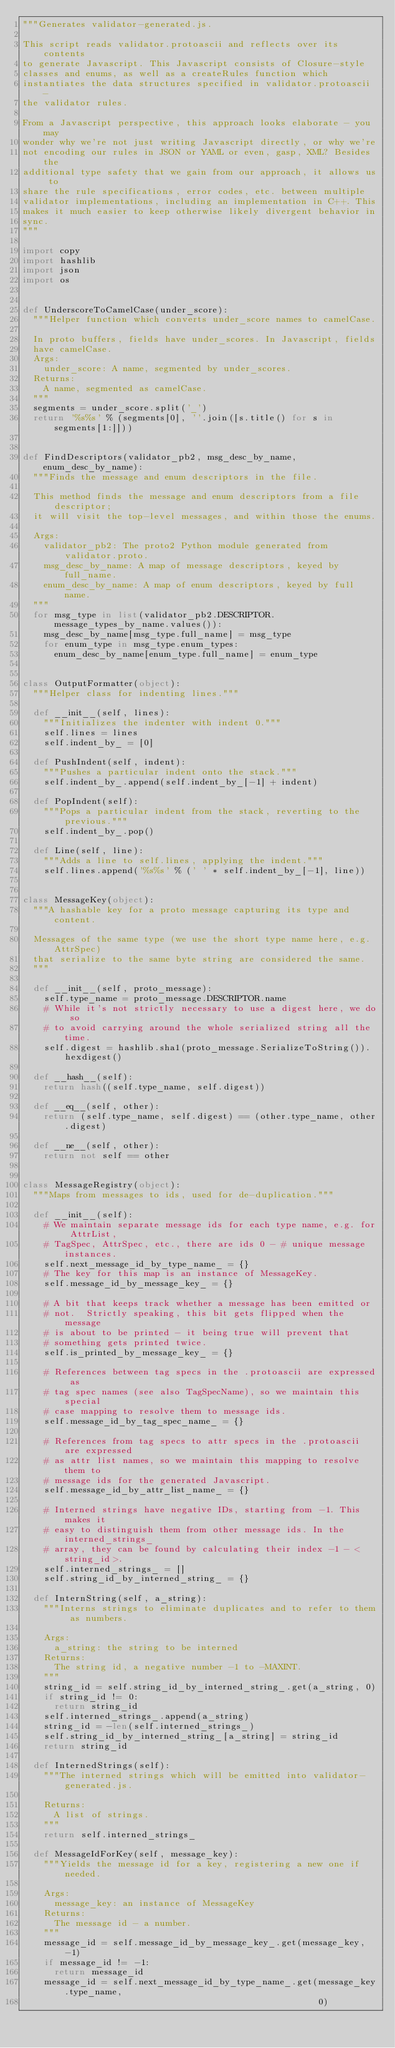Convert code to text. <code><loc_0><loc_0><loc_500><loc_500><_Python_>"""Generates validator-generated.js.

This script reads validator.protoascii and reflects over its contents
to generate Javascript. This Javascript consists of Closure-style
classes and enums, as well as a createRules function which
instantiates the data structures specified in validator.protoascii -
the validator rules.

From a Javascript perspective, this approach looks elaborate - you may
wonder why we're not just writing Javascript directly, or why we're
not encoding our rules in JSON or YAML or even, gasp, XML? Besides the
additional type safety that we gain from our approach, it allows us to
share the rule specifications, error codes, etc. between multiple
validator implementations, including an implementation in C++. This
makes it much easier to keep otherwise likely divergent behavior in
sync.
"""

import copy
import hashlib
import json
import os


def UnderscoreToCamelCase(under_score):
  """Helper function which converts under_score names to camelCase.

  In proto buffers, fields have under_scores. In Javascript, fields
  have camelCase.
  Args:
    under_score: A name, segmented by under_scores.
  Returns:
    A name, segmented as camelCase.
  """
  segments = under_score.split('_')
  return '%s%s' % (segments[0], ''.join([s.title() for s in segments[1:]]))


def FindDescriptors(validator_pb2, msg_desc_by_name, enum_desc_by_name):
  """Finds the message and enum descriptors in the file.

  This method finds the message and enum descriptors from a file descriptor;
  it will visit the top-level messages, and within those the enums.

  Args:
    validator_pb2: The proto2 Python module generated from validator.proto.
    msg_desc_by_name: A map of message descriptors, keyed by full_name.
    enum_desc_by_name: A map of enum descriptors, keyed by full name.
  """
  for msg_type in list(validator_pb2.DESCRIPTOR.message_types_by_name.values()):
    msg_desc_by_name[msg_type.full_name] = msg_type
    for enum_type in msg_type.enum_types:
      enum_desc_by_name[enum_type.full_name] = enum_type


class OutputFormatter(object):
  """Helper class for indenting lines."""

  def __init__(self, lines):
    """Initializes the indenter with indent 0."""
    self.lines = lines
    self.indent_by_ = [0]

  def PushIndent(self, indent):
    """Pushes a particular indent onto the stack."""
    self.indent_by_.append(self.indent_by_[-1] + indent)

  def PopIndent(self):
    """Pops a particular indent from the stack, reverting to the previous."""
    self.indent_by_.pop()

  def Line(self, line):
    """Adds a line to self.lines, applying the indent."""
    self.lines.append('%s%s' % (' ' * self.indent_by_[-1], line))


class MessageKey(object):
  """A hashable key for a proto message capturing its type and content.

  Messages of the same type (we use the short type name here, e.g. AttrSpec)
  that serialize to the same byte string are considered the same.
  """

  def __init__(self, proto_message):
    self.type_name = proto_message.DESCRIPTOR.name
    # While it's not strictly necessary to use a digest here, we do so
    # to avoid carrying around the whole serialized string all the time.
    self.digest = hashlib.sha1(proto_message.SerializeToString()).hexdigest()

  def __hash__(self):
    return hash((self.type_name, self.digest))

  def __eq__(self, other):
    return (self.type_name, self.digest) == (other.type_name, other.digest)

  def __ne__(self, other):
    return not self == other


class MessageRegistry(object):
  """Maps from messages to ids, used for de-duplication."""

  def __init__(self):
    # We maintain separate message ids for each type name, e.g. for AttrList,
    # TagSpec, AttrSpec, etc., there are ids 0 - # unique message instances.
    self.next_message_id_by_type_name_ = {}
    # The key for this map is an instance of MessageKey.
    self.message_id_by_message_key_ = {}

    # A bit that keeps track whether a message has been emitted or
    # not.  Strictly speaking, this bit gets flipped when the message
    # is about to be printed - it being true will prevent that
    # something gets printed twice.
    self.is_printed_by_message_key_ = {}

    # References between tag specs in the .protoascii are expressed as
    # tag spec names (see also TagSpecName), so we maintain this special
    # case mapping to resolve them to message ids.
    self.message_id_by_tag_spec_name_ = {}

    # References from tag specs to attr specs in the .protoascii are expressed
    # as attr list names, so we maintain this mapping to resolve them to
    # message ids for the generated Javascript.
    self.message_id_by_attr_list_name_ = {}

    # Interned strings have negative IDs, starting from -1. This makes it
    # easy to distinguish them from other message ids. In the interned_strings_
    # array, they can be found by calculating their index -1 - <string_id>.
    self.interned_strings_ = []
    self.string_id_by_interned_string_ = {}

  def InternString(self, a_string):
    """Interns strings to eliminate duplicates and to refer to them as numbers.

    Args:
      a_string: the string to be interned
    Returns:
      The string id, a negative number -1 to -MAXINT.
    """
    string_id = self.string_id_by_interned_string_.get(a_string, 0)
    if string_id != 0:
      return string_id
    self.interned_strings_.append(a_string)
    string_id = -len(self.interned_strings_)
    self.string_id_by_interned_string_[a_string] = string_id
    return string_id

  def InternedStrings(self):
    """The interned strings which will be emitted into validator-generated.js.

    Returns:
      A list of strings.
    """
    return self.interned_strings_

  def MessageIdForKey(self, message_key):
    """Yields the message id for a key, registering a new one if needed.

    Args:
      message_key: an instance of MessageKey
    Returns:
      The message id - a number.
    """
    message_id = self.message_id_by_message_key_.get(message_key, -1)
    if message_id != -1:
      return message_id
    message_id = self.next_message_id_by_type_name_.get(message_key.type_name,
                                                        0)</code> 